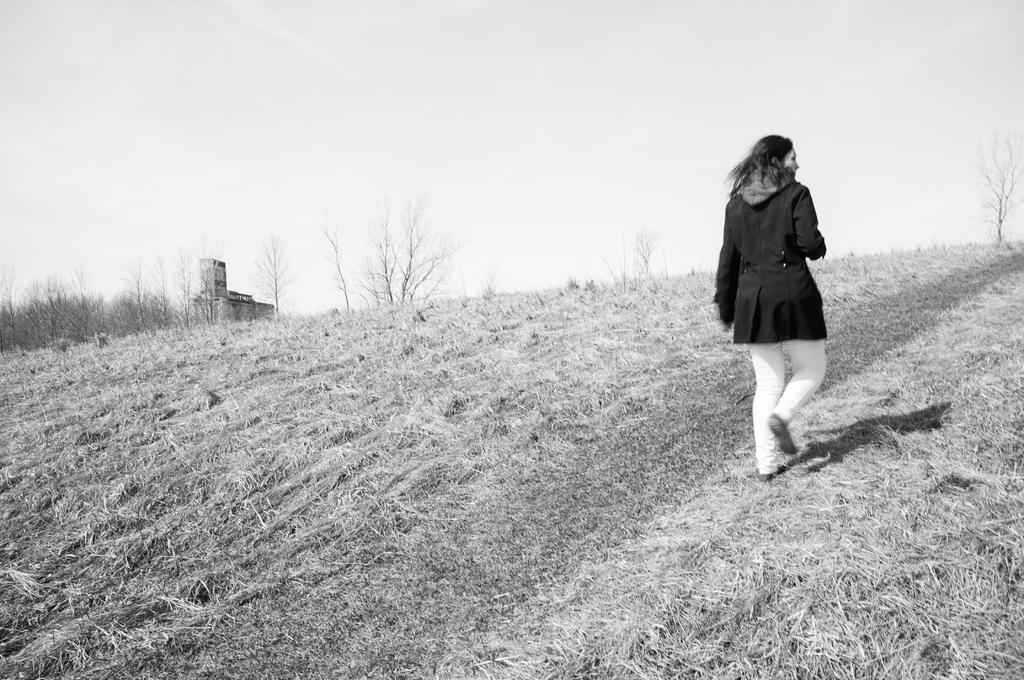Can you describe this image briefly? On the right side of the image we can see a lady walking. At the bottom there is grass. In the background there are trees and sky. 